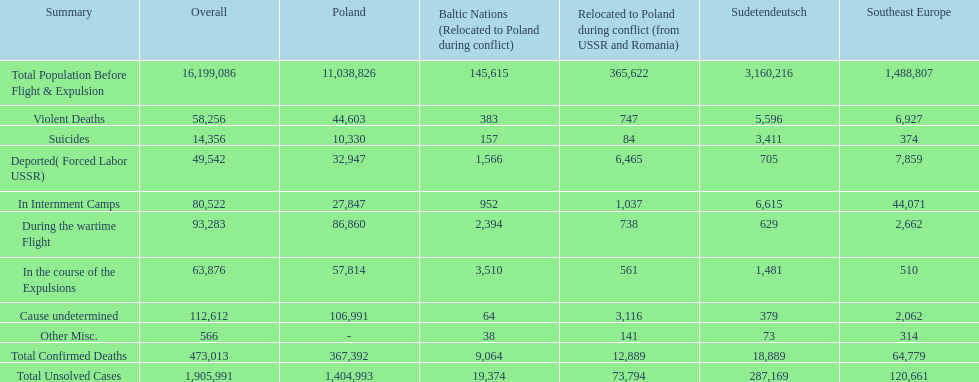Was there a larger total population before expulsion in poland or sudetendeutsch? Poland. 